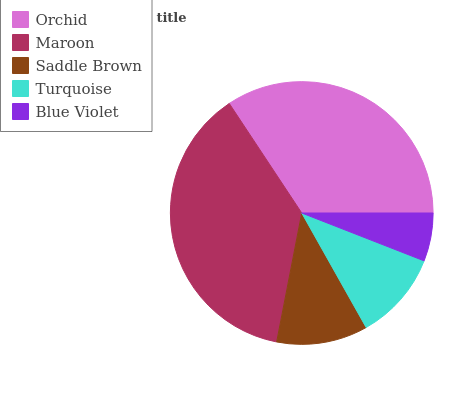Is Blue Violet the minimum?
Answer yes or no. Yes. Is Maroon the maximum?
Answer yes or no. Yes. Is Saddle Brown the minimum?
Answer yes or no. No. Is Saddle Brown the maximum?
Answer yes or no. No. Is Maroon greater than Saddle Brown?
Answer yes or no. Yes. Is Saddle Brown less than Maroon?
Answer yes or no. Yes. Is Saddle Brown greater than Maroon?
Answer yes or no. No. Is Maroon less than Saddle Brown?
Answer yes or no. No. Is Saddle Brown the high median?
Answer yes or no. Yes. Is Saddle Brown the low median?
Answer yes or no. Yes. Is Orchid the high median?
Answer yes or no. No. Is Orchid the low median?
Answer yes or no. No. 